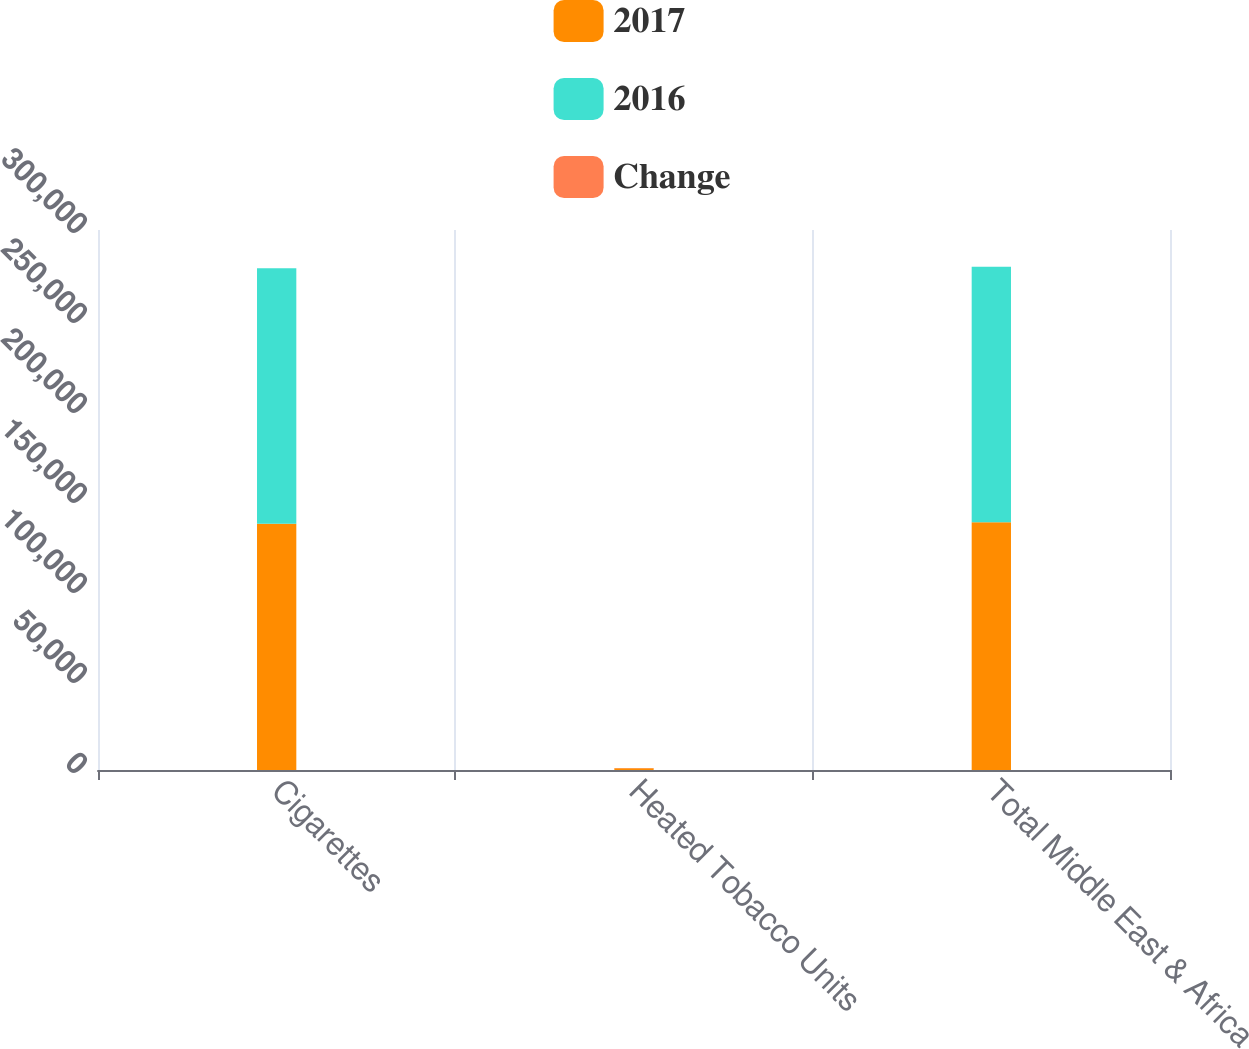Convert chart. <chart><loc_0><loc_0><loc_500><loc_500><stacked_bar_chart><ecel><fcel>Cigarettes<fcel>Heated Tobacco Units<fcel>Total Middle East & Africa<nl><fcel>2017<fcel>136759<fcel>907<fcel>137666<nl><fcel>2016<fcel>141937<fcel>36<fcel>141973<nl><fcel>Change<fcel>3.6<fcel>100<fcel>3<nl></chart> 